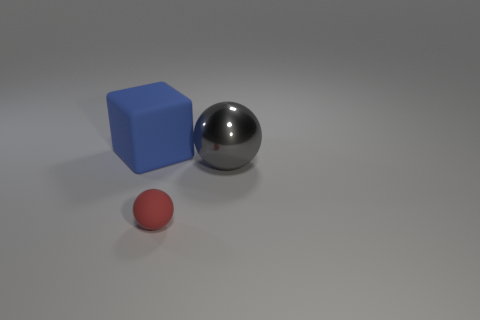Add 1 balls. How many objects exist? 4 Subtract all spheres. How many objects are left? 1 Subtract 0 brown blocks. How many objects are left? 3 Subtract all big blue objects. Subtract all cubes. How many objects are left? 1 Add 3 blue matte objects. How many blue matte objects are left? 4 Add 1 green metallic things. How many green metallic things exist? 1 